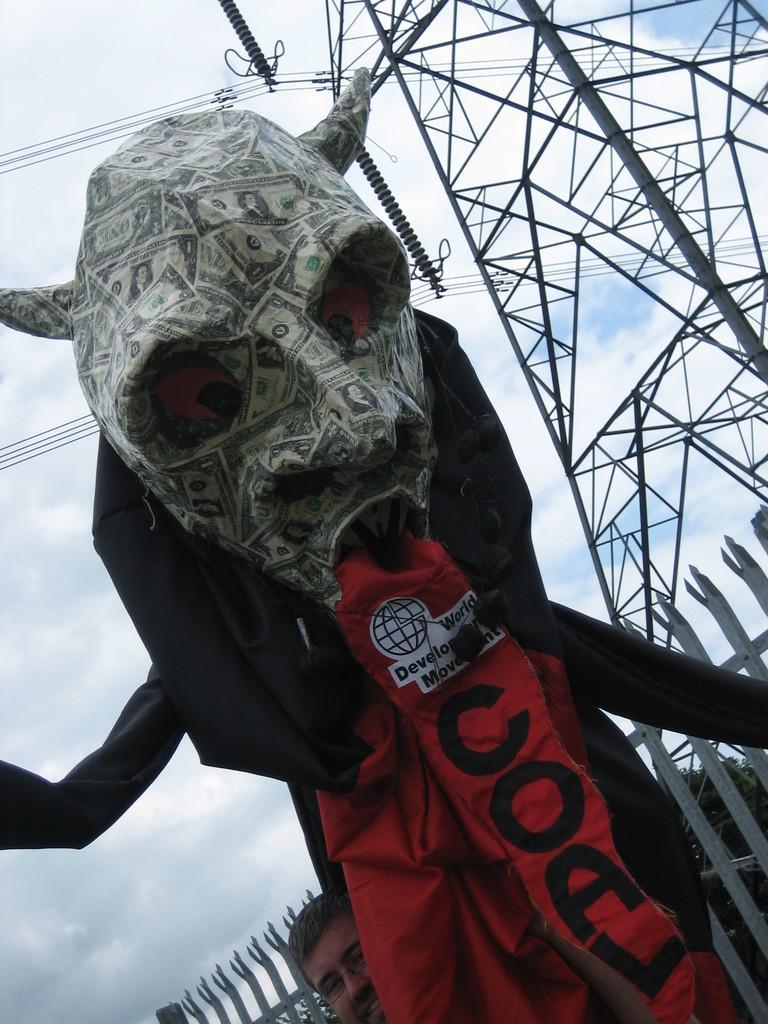How would you summarize this image in a sentence or two? In the middle of this image, there is a statue. Beside this statue, there is a person smiling. In the background, there is a fence, a tower having transmission lines and there are clouds in the blue sky. 